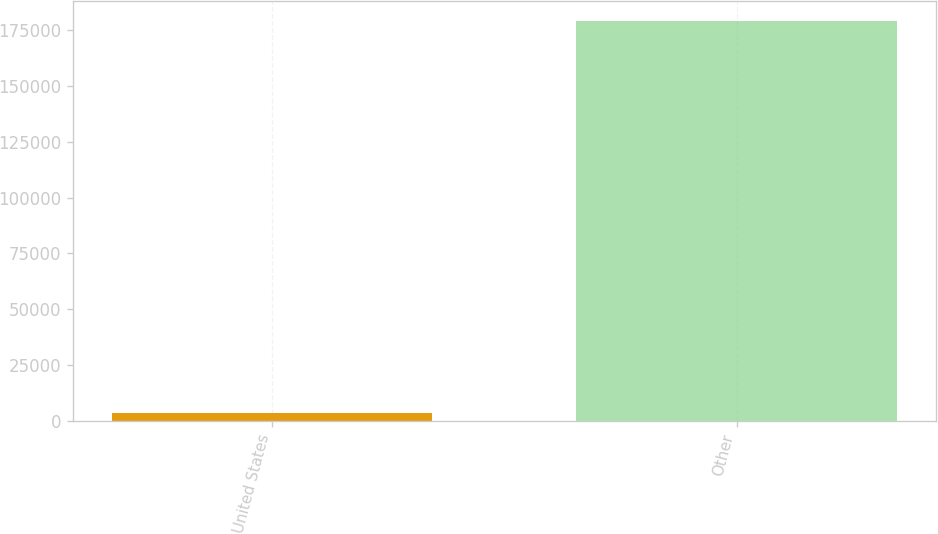Convert chart to OTSL. <chart><loc_0><loc_0><loc_500><loc_500><bar_chart><fcel>United States<fcel>Other<nl><fcel>3323<fcel>179053<nl></chart> 